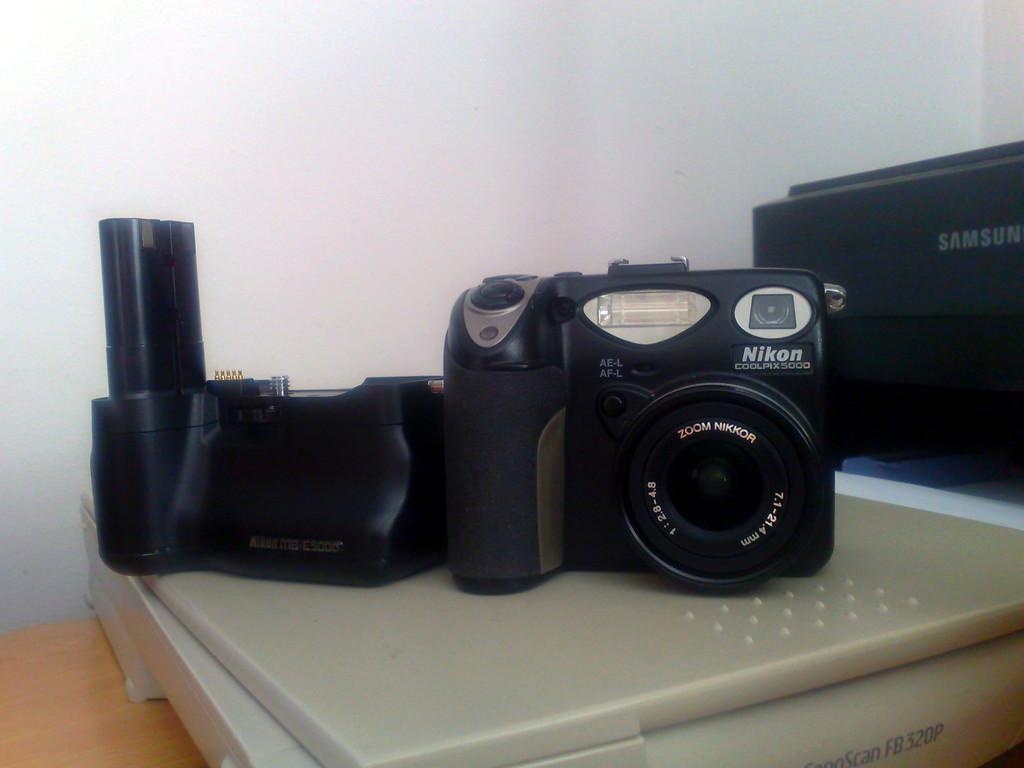What devices are present on the surface of the scanner in the image? There are cameras on the surface of the scanner in the image. What brand and color is the object on the right side of the image? The object on the right side of the image is a black color Samsung object. What can be seen in the background of the image? There is a plain wall in the background of the image. How far away is the dad from the scanner in the image? There is no dad present in the image, so it is not possible to determine the distance between him and the scanner. What page of the book is being scanned in the image? There is no book present in the image, so it is not possible to determine which page is being scanned. 